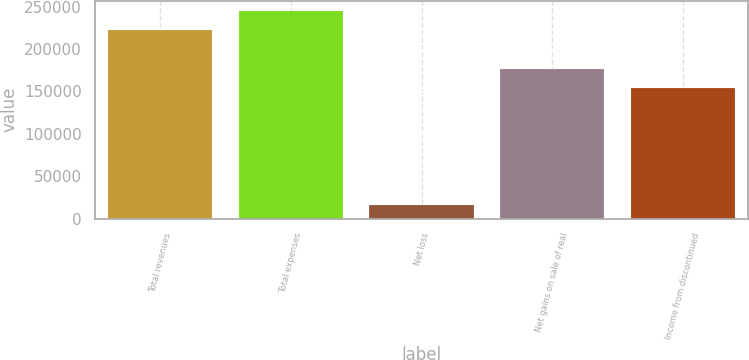Convert chart to OTSL. <chart><loc_0><loc_0><loc_500><loc_500><bar_chart><fcel>Total revenues<fcel>Total expenses<fcel>Net loss<fcel>Net gains on sale of real<fcel>Income from discontinued<nl><fcel>222361<fcel>244597<fcel>15771<fcel>176678<fcel>154442<nl></chart> 